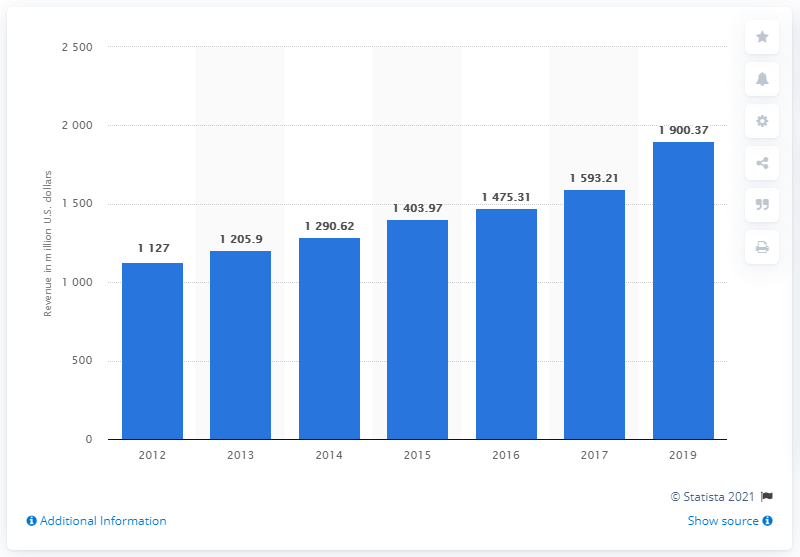Highlight a few significant elements in this photo. In 2019, the revenue of Life Time Fitness, Inc. was 1,900.37 million dollars. 